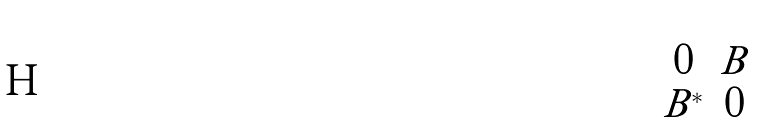<formula> <loc_0><loc_0><loc_500><loc_500>\begin{pmatrix} 0 & B \\ B ^ { * } & 0 \end{pmatrix}</formula> 